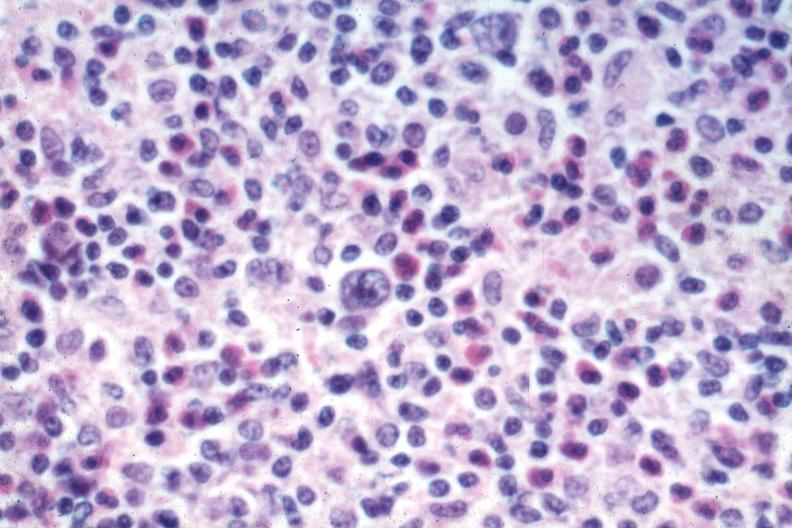does this image show typical with reed sternberg cell source?
Answer the question using a single word or phrase. Yes 